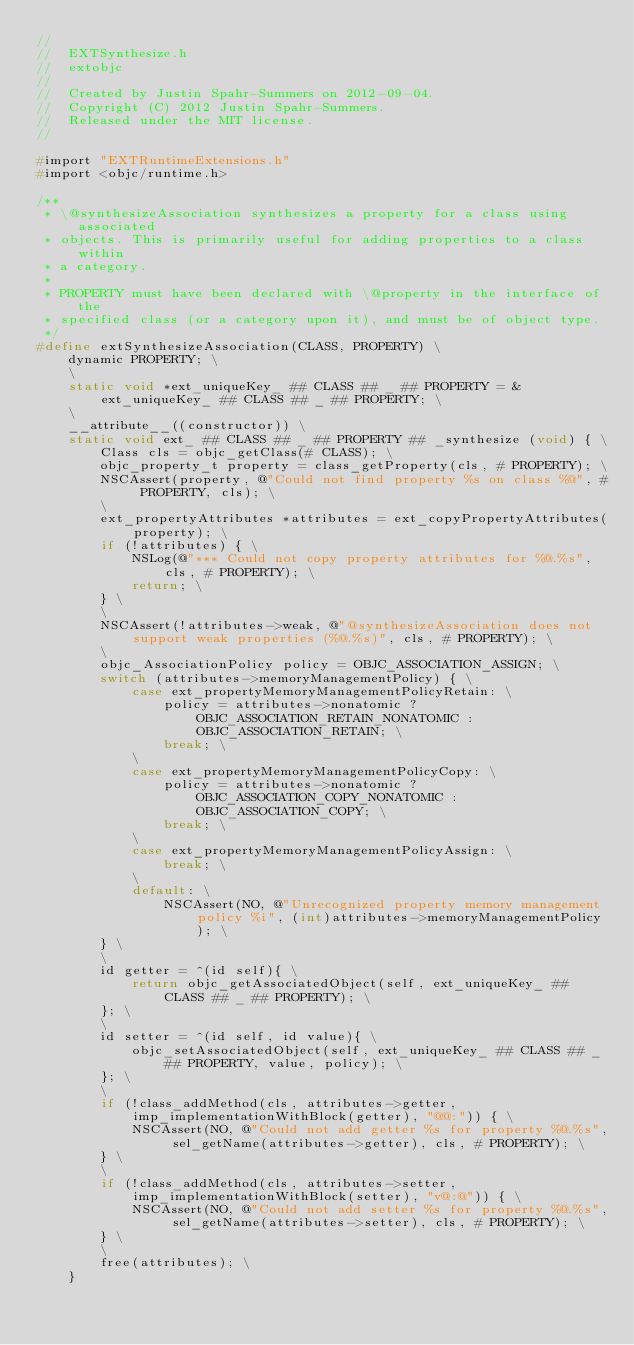<code> <loc_0><loc_0><loc_500><loc_500><_C_>//
//  EXTSynthesize.h
//  extobjc
//
//  Created by Justin Spahr-Summers on 2012-09-04.
//  Copyright (C) 2012 Justin Spahr-Summers.
//  Released under the MIT license.
//

#import "EXTRuntimeExtensions.h"
#import <objc/runtime.h>

/**
 * \@synthesizeAssociation synthesizes a property for a class using associated
 * objects. This is primarily useful for adding properties to a class within
 * a category.
 *
 * PROPERTY must have been declared with \@property in the interface of the
 * specified class (or a category upon it), and must be of object type.
 */
#define extSynthesizeAssociation(CLASS, PROPERTY) \
	dynamic PROPERTY; \
	\
	static void *ext_uniqueKey_ ## CLASS ## _ ## PROPERTY = &ext_uniqueKey_ ## CLASS ## _ ## PROPERTY; \
	\
	__attribute__((constructor)) \
	static void ext_ ## CLASS ## _ ## PROPERTY ## _synthesize (void) { \
		Class cls = objc_getClass(# CLASS); \
		objc_property_t property = class_getProperty(cls, # PROPERTY); \
		NSCAssert(property, @"Could not find property %s on class %@", # PROPERTY, cls); \
		\
		ext_propertyAttributes *attributes = ext_copyPropertyAttributes(property); \
		if (!attributes) { \
			NSLog(@"*** Could not copy property attributes for %@.%s", cls, # PROPERTY); \
			return; \
		} \
		\
		NSCAssert(!attributes->weak, @"@synthesizeAssociation does not support weak properties (%@.%s)", cls, # PROPERTY); \
		\
		objc_AssociationPolicy policy = OBJC_ASSOCIATION_ASSIGN; \
		switch (attributes->memoryManagementPolicy) { \
			case ext_propertyMemoryManagementPolicyRetain: \
				policy = attributes->nonatomic ? OBJC_ASSOCIATION_RETAIN_NONATOMIC : OBJC_ASSOCIATION_RETAIN; \
				break; \
			\
			case ext_propertyMemoryManagementPolicyCopy: \
				policy = attributes->nonatomic ? OBJC_ASSOCIATION_COPY_NONATOMIC : OBJC_ASSOCIATION_COPY; \
				break; \
			\
			case ext_propertyMemoryManagementPolicyAssign: \
				break; \
			\
			default: \
				NSCAssert(NO, @"Unrecognized property memory management policy %i", (int)attributes->memoryManagementPolicy); \
		} \
		\
		id getter = ^(id self){ \
			return objc_getAssociatedObject(self, ext_uniqueKey_ ## CLASS ## _ ## PROPERTY); \
		}; \
		\
		id setter = ^(id self, id value){ \
			objc_setAssociatedObject(self, ext_uniqueKey_ ## CLASS ## _ ## PROPERTY, value, policy); \
		}; \
		\
		if (!class_addMethod(cls, attributes->getter, imp_implementationWithBlock(getter), "@@:")) { \
			NSCAssert(NO, @"Could not add getter %s for property %@.%s", sel_getName(attributes->getter), cls, # PROPERTY); \
		} \
		\
		if (!class_addMethod(cls, attributes->setter, imp_implementationWithBlock(setter), "v@:@")) { \
			NSCAssert(NO, @"Could not add setter %s for property %@.%s", sel_getName(attributes->setter), cls, # PROPERTY); \
		} \
		\
		free(attributes); \
	}
</code> 